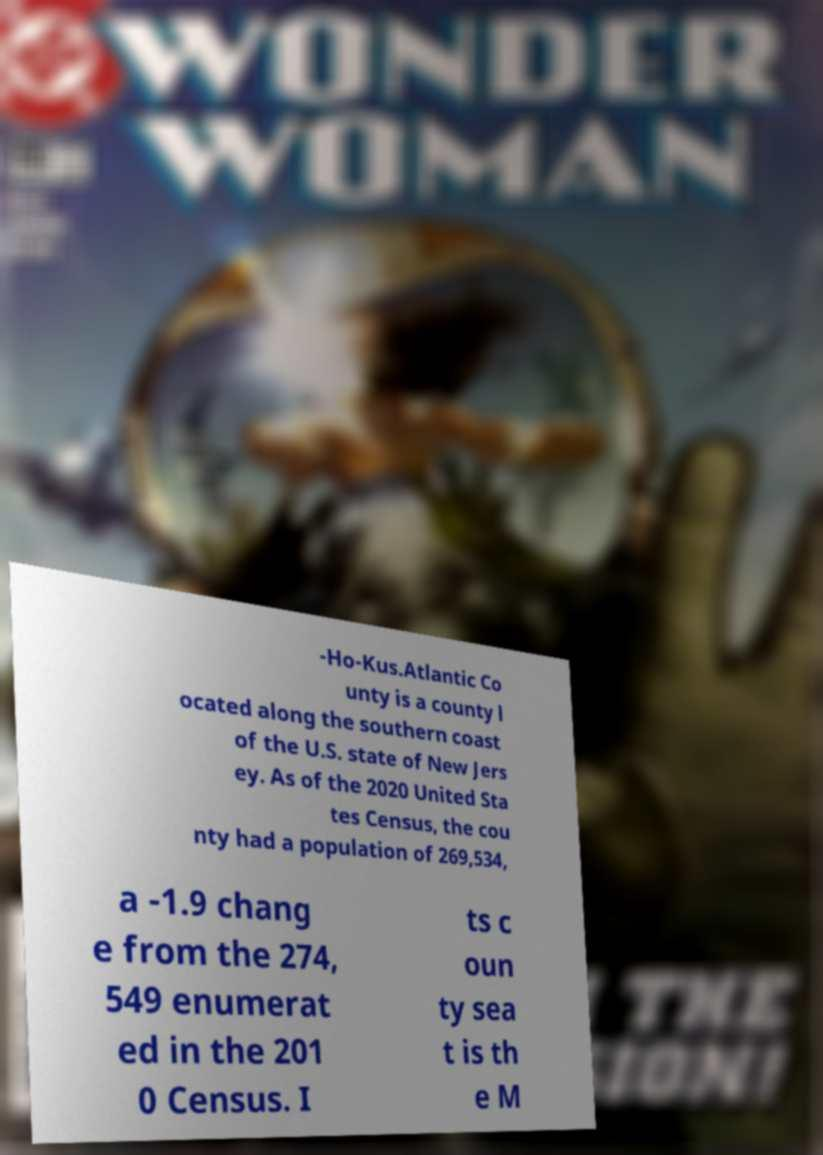Can you read and provide the text displayed in the image?This photo seems to have some interesting text. Can you extract and type it out for me? -Ho-Kus.Atlantic Co unty is a county l ocated along the southern coast of the U.S. state of New Jers ey. As of the 2020 United Sta tes Census, the cou nty had a population of 269,534, a -1.9 chang e from the 274, 549 enumerat ed in the 201 0 Census. I ts c oun ty sea t is th e M 